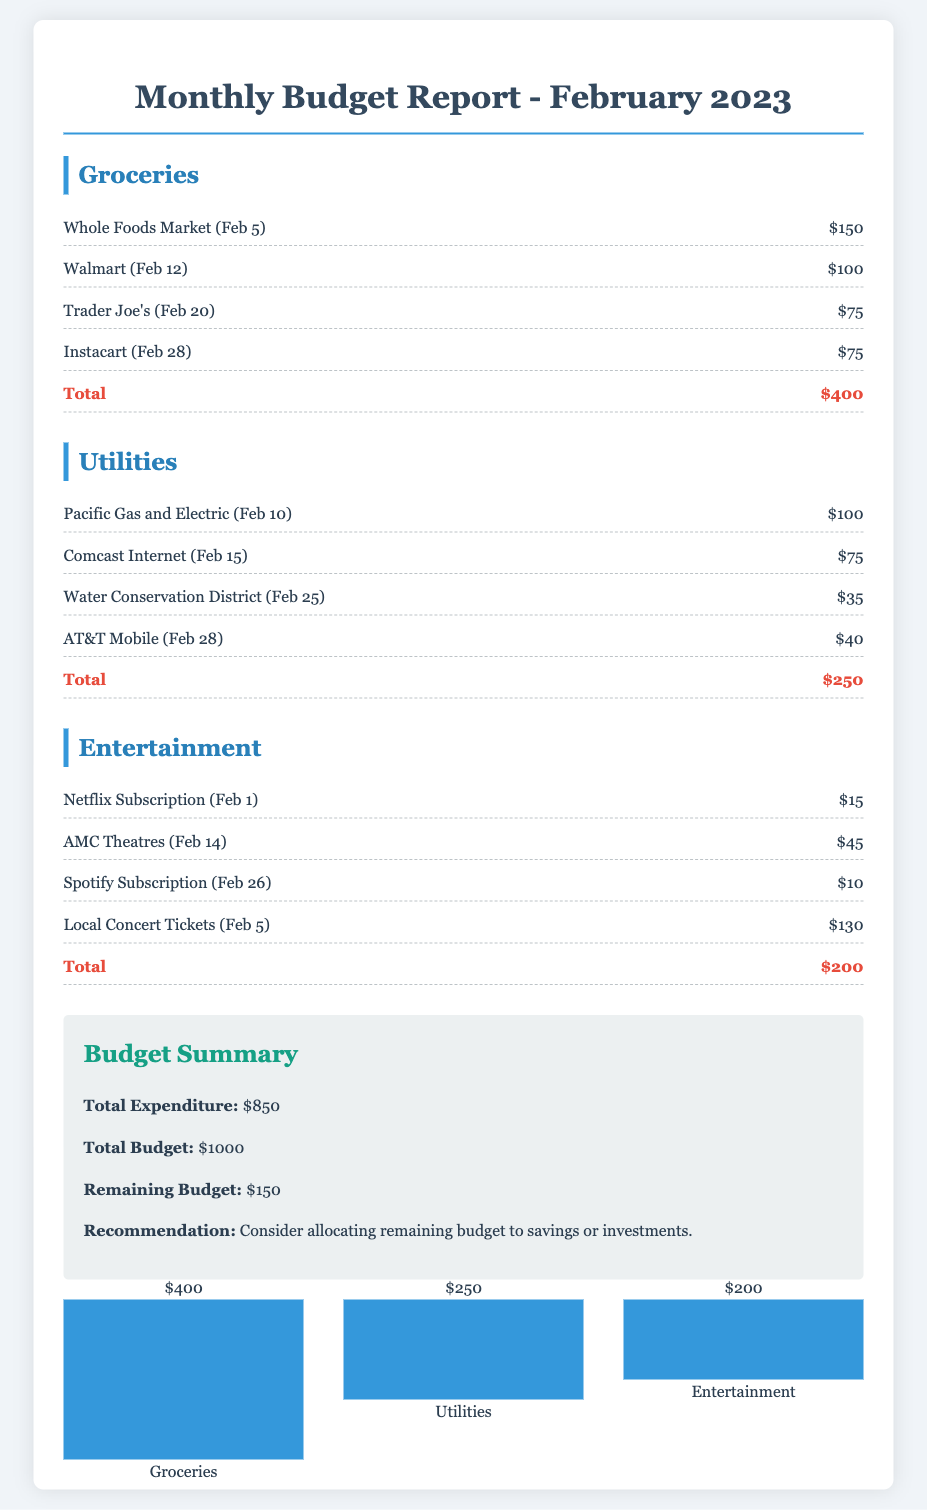What is the total expenditure for February 2023? The total expenditure is calculated by adding all expenses across categories: $400 + $250 + $200 = $850.
Answer: $850 What was spent on groceries? The total spent on groceries is listed clearly at the bottom of the groceries section and is $400.
Answer: $400 What is the amount allocated to utilities? The total amount allocated to utilities is calculated at the end of the utilities section and is $250.
Answer: $250 What are the entertainment expenses? The total entertainment expenses are provided at the end of the entertainment section as $200.
Answer: $200 What is the remaining budget after expenditures? The remaining budget is found in the summary section, calculated by subtracting total expenditure from total budget: $1000 - $850 = $150.
Answer: $150 Which grocery store has the highest expenditure? The highest grocery expenditure can be identified within the groceries section; Whole Foods Market has the highest expense of $150.
Answer: Whole Foods Market What is the budget recommendation provided in the document? The recommendation in the summary section advises on how to best utilize the remaining budget, specifically suggesting savings or investments.
Answer: Consider allocating remaining budget to savings or investments How many categories are listed in the budget report? The document lists three distinct categories for budgeting expenditures: groceries, utilities, and entertainment.
Answer: Three What was the payment date for the Netflix subscription? The date for the Netflix subscription can be found in the entertainment section; it states February 1.
Answer: February 1 